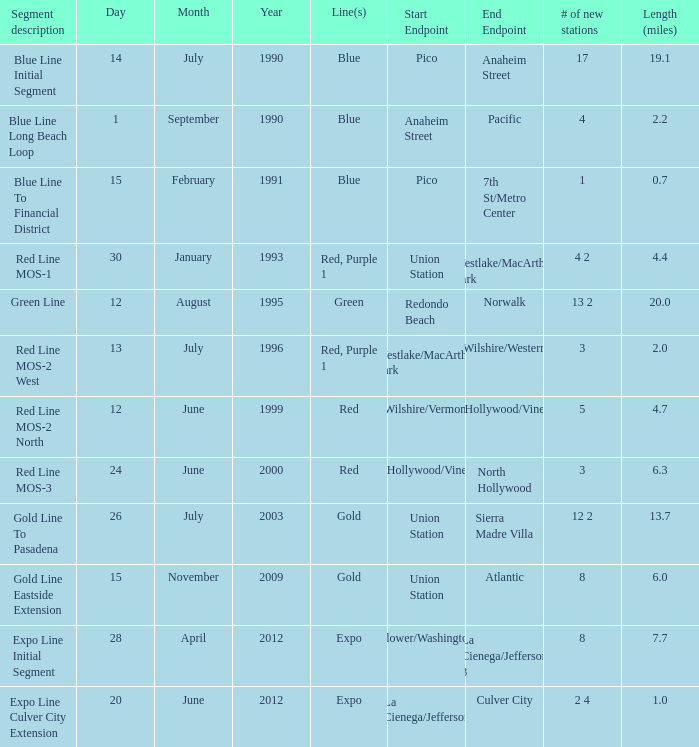How many news channels were launched on june 24, 2000? 3.0. 